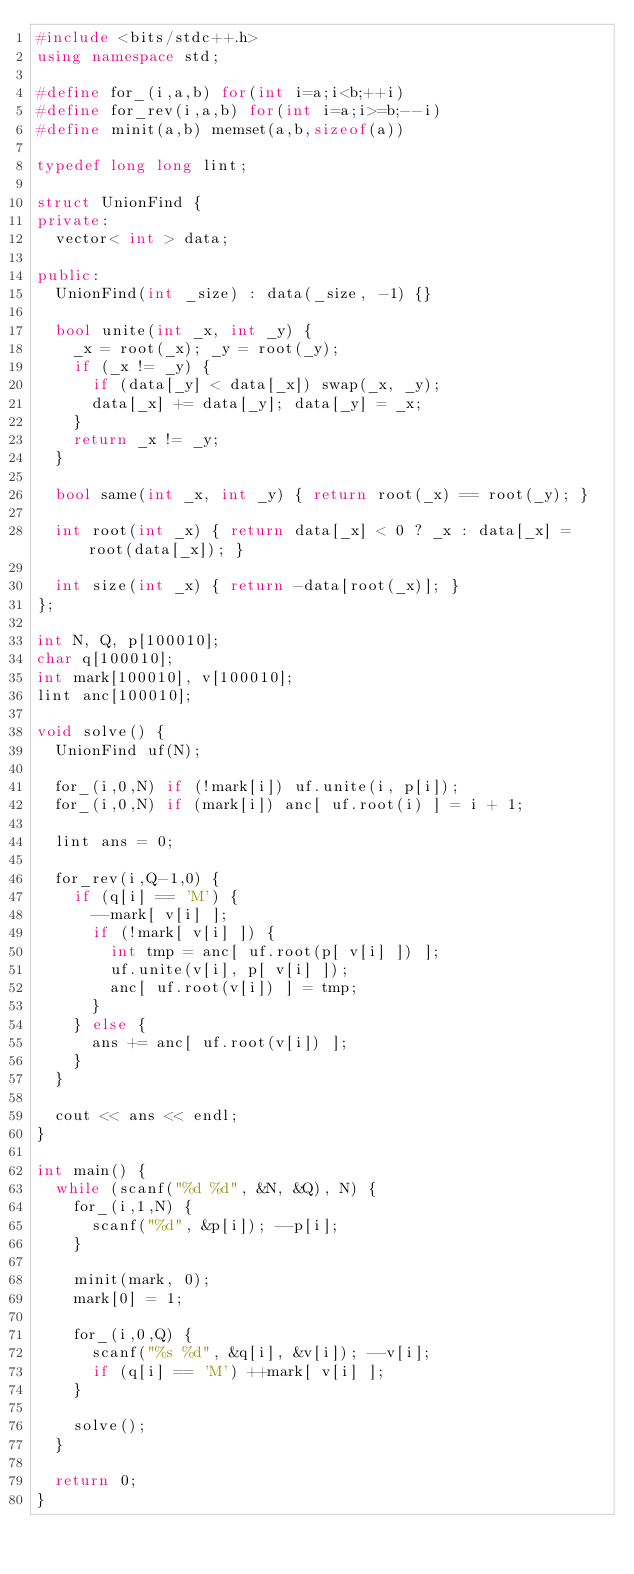Convert code to text. <code><loc_0><loc_0><loc_500><loc_500><_C++_>#include <bits/stdc++.h>
using namespace std;

#define for_(i,a,b) for(int i=a;i<b;++i)
#define for_rev(i,a,b) for(int i=a;i>=b;--i)
#define minit(a,b) memset(a,b,sizeof(a))

typedef long long lint;

struct UnionFind {
private:
	vector< int > data;
	
public:
	UnionFind(int _size) : data(_size, -1) {}
	
	bool unite(int _x, int _y) {
		_x = root(_x); _y = root(_y);
		if (_x != _y) {
			if (data[_y] < data[_x]) swap(_x, _y);
			data[_x] += data[_y]; data[_y] = _x;
		}
		return _x != _y;
	}
	
	bool same(int _x, int _y) { return root(_x) == root(_y); }
	
	int root(int _x) { return data[_x] < 0 ? _x : data[_x] = root(data[_x]); }
	
	int size(int _x) { return -data[root(_x)]; }
};

int N, Q, p[100010];
char q[100010];
int mark[100010], v[100010];
lint anc[100010];

void solve() {
	UnionFind uf(N);
	
	for_(i,0,N) if (!mark[i]) uf.unite(i, p[i]);
	for_(i,0,N) if (mark[i]) anc[ uf.root(i) ] = i + 1;
	
	lint ans = 0;
	
	for_rev(i,Q-1,0) {
		if (q[i] == 'M') {
			--mark[ v[i] ];
			if (!mark[ v[i] ]) {
				int tmp = anc[ uf.root(p[ v[i] ]) ];
				uf.unite(v[i], p[ v[i] ]);
				anc[ uf.root(v[i]) ] = tmp;
			}
		} else {
			ans += anc[ uf.root(v[i]) ];
		}
	}
	
	cout << ans << endl;
}

int main() {
	while (scanf("%d %d", &N, &Q), N) {
		for_(i,1,N) {
			scanf("%d", &p[i]); --p[i];
		}
		
		minit(mark, 0);
		mark[0] = 1;
		
		for_(i,0,Q) {
			scanf("%s %d", &q[i], &v[i]); --v[i];
			if (q[i] == 'M') ++mark[ v[i] ];
		}
		
		solve();
	}
	
	return 0;
}</code> 